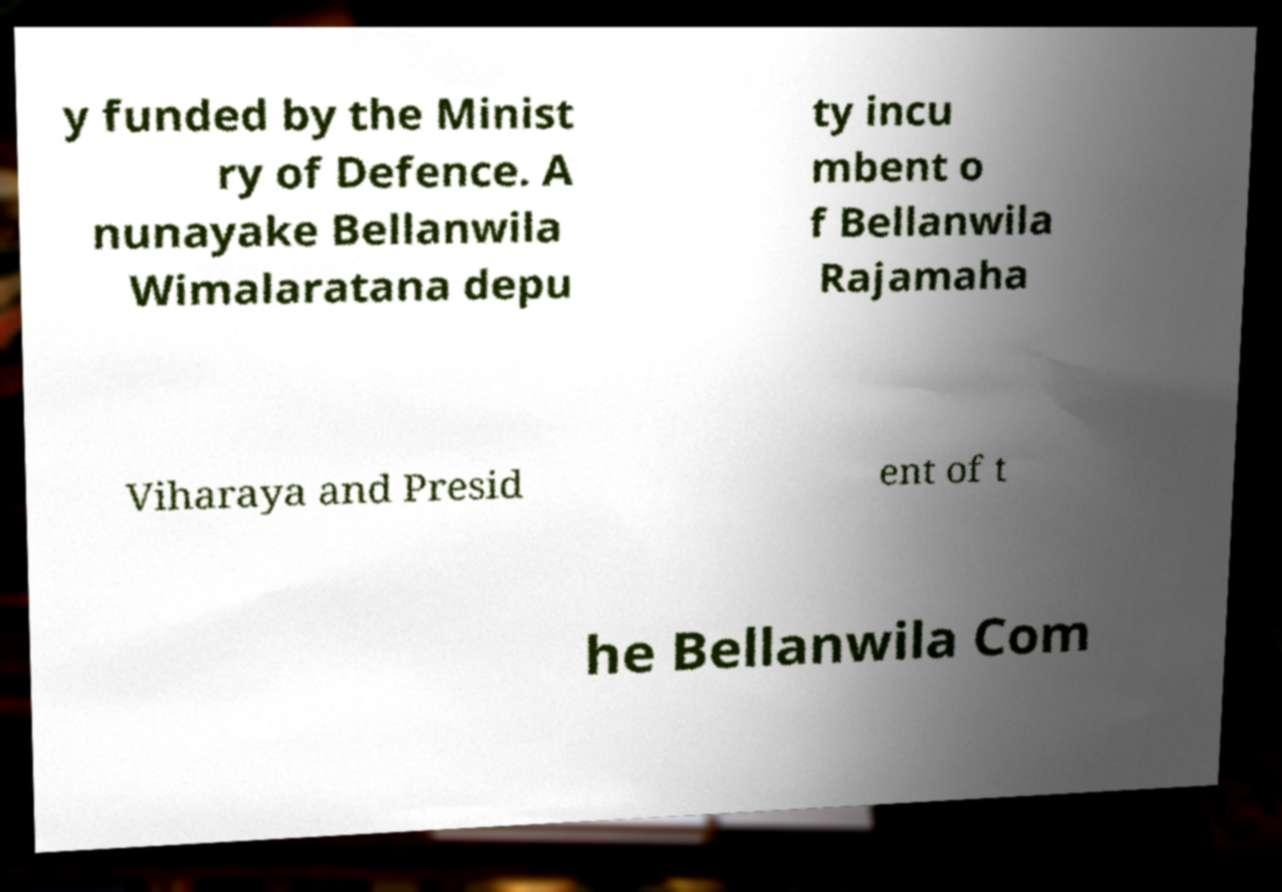I need the written content from this picture converted into text. Can you do that? y funded by the Minist ry of Defence. A nunayake Bellanwila Wimalaratana depu ty incu mbent o f Bellanwila Rajamaha Viharaya and Presid ent of t he Bellanwila Com 